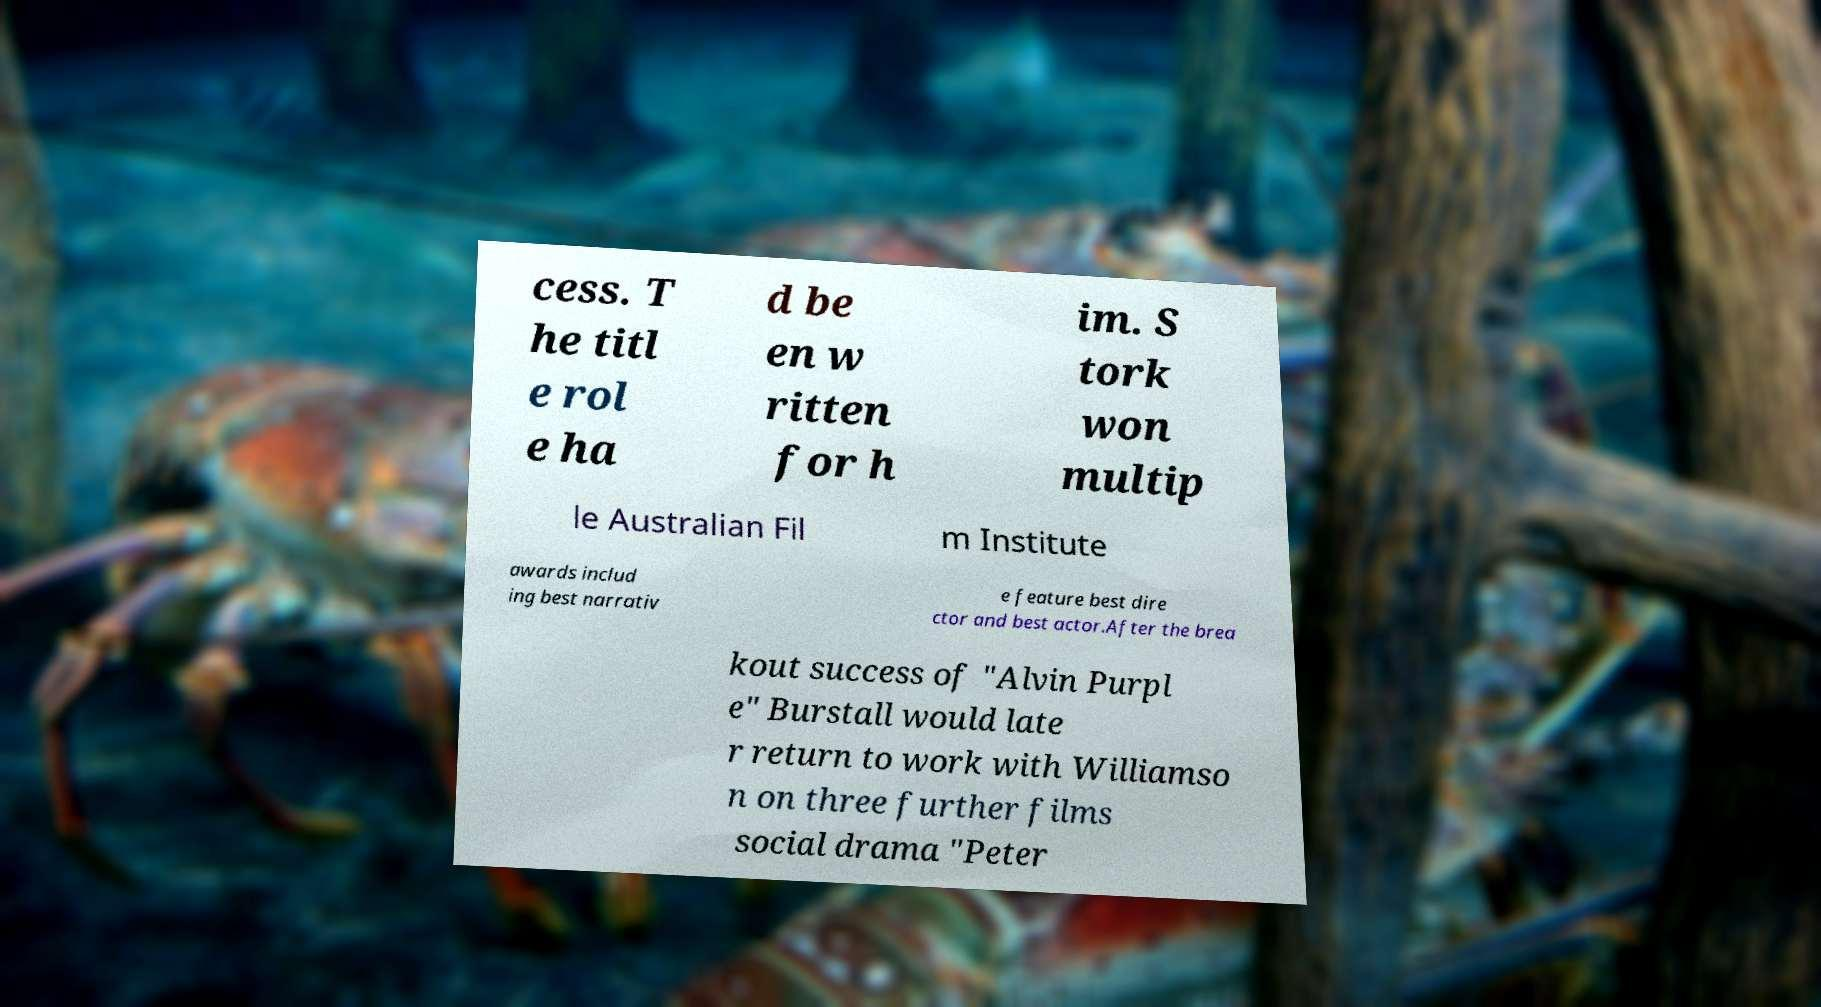Can you read and provide the text displayed in the image?This photo seems to have some interesting text. Can you extract and type it out for me? cess. T he titl e rol e ha d be en w ritten for h im. S tork won multip le Australian Fil m Institute awards includ ing best narrativ e feature best dire ctor and best actor.After the brea kout success of "Alvin Purpl e" Burstall would late r return to work with Williamso n on three further films social drama "Peter 